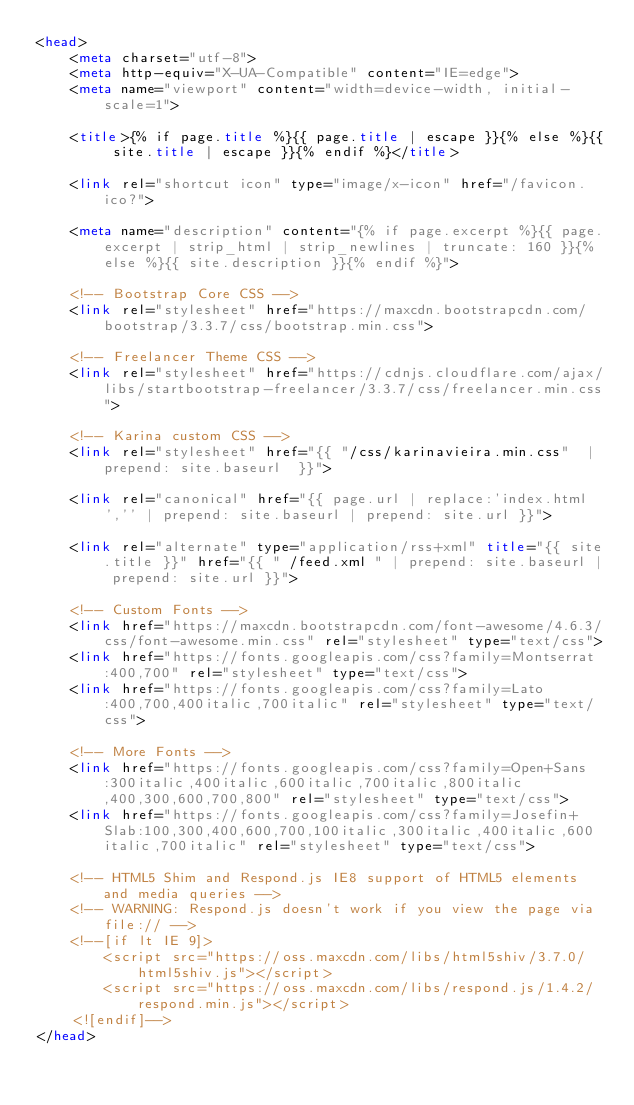Convert code to text. <code><loc_0><loc_0><loc_500><loc_500><_HTML_><head>
    <meta charset="utf-8">
    <meta http-equiv="X-UA-Compatible" content="IE=edge">
    <meta name="viewport" content="width=device-width, initial-scale=1">

    <title>{% if page.title %}{{ page.title | escape }}{% else %}{{ site.title | escape }}{% endif %}</title>

    <link rel="shortcut icon" type="image/x-icon" href="/favicon.ico?">

    <meta name="description" content="{% if page.excerpt %}{{ page.excerpt | strip_html | strip_newlines | truncate: 160 }}{% else %}{{ site.description }}{% endif %}">

    <!-- Bootstrap Core CSS -->
    <link rel="stylesheet" href="https://maxcdn.bootstrapcdn.com/bootstrap/3.3.7/css/bootstrap.min.css">

    <!-- Freelancer Theme CSS -->
    <link rel="stylesheet" href="https://cdnjs.cloudflare.com/ajax/libs/startbootstrap-freelancer/3.3.7/css/freelancer.min.css">

    <!-- Karina custom CSS -->
    <link rel="stylesheet" href="{{ "/css/karinavieira.min.css"  | prepend: site.baseurl  }}">

    <link rel="canonical" href="{{ page.url | replace:'index.html','' | prepend: site.baseurl | prepend: site.url }}">

    <link rel="alternate" type="application/rss+xml" title="{{ site.title }}" href="{{ " /feed.xml " | prepend: site.baseurl | prepend: site.url }}">

    <!-- Custom Fonts -->
    <link href="https://maxcdn.bootstrapcdn.com/font-awesome/4.6.3/css/font-awesome.min.css" rel="stylesheet" type="text/css">
    <link href="https://fonts.googleapis.com/css?family=Montserrat:400,700" rel="stylesheet" type="text/css">
    <link href="https://fonts.googleapis.com/css?family=Lato:400,700,400italic,700italic" rel="stylesheet" type="text/css">

    <!-- More Fonts -->
    <link href="https://fonts.googleapis.com/css?family=Open+Sans:300italic,400italic,600italic,700italic,800italic,400,300,600,700,800" rel="stylesheet" type="text/css">
    <link href="https://fonts.googleapis.com/css?family=Josefin+Slab:100,300,400,600,700,100italic,300italic,400italic,600italic,700italic" rel="stylesheet" type="text/css">

    <!-- HTML5 Shim and Respond.js IE8 support of HTML5 elements and media queries -->
    <!-- WARNING: Respond.js doesn't work if you view the page via file:// -->
    <!--[if lt IE 9]>
        <script src="https://oss.maxcdn.com/libs/html5shiv/3.7.0/html5shiv.js"></script>
        <script src="https://oss.maxcdn.com/libs/respond.js/1.4.2/respond.min.js"></script>
    <![endif]-->
</head>
</code> 